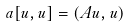<formula> <loc_0><loc_0><loc_500><loc_500>a [ u , u ] = ( A u , u )</formula> 